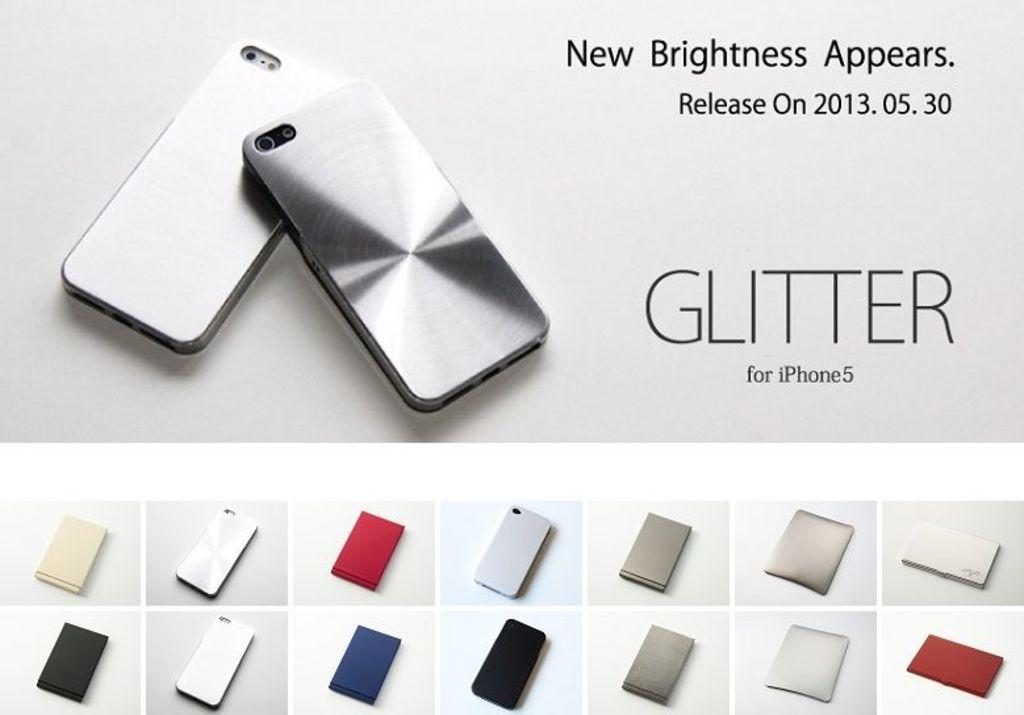<image>
Describe the image concisely. An advertisment for Glitter for iPhone 5 showing different colors. 